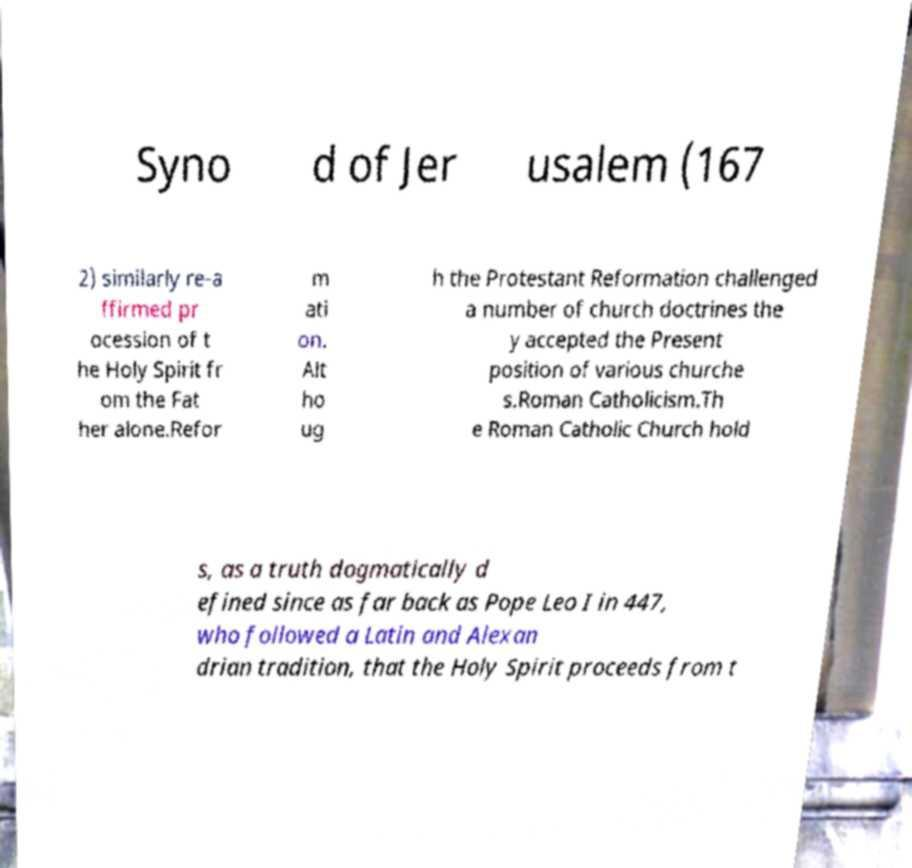There's text embedded in this image that I need extracted. Can you transcribe it verbatim? Syno d of Jer usalem (167 2) similarly re-a ffirmed pr ocession of t he Holy Spirit fr om the Fat her alone.Refor m ati on. Alt ho ug h the Protestant Reformation challenged a number of church doctrines the y accepted the Present position of various churche s.Roman Catholicism.Th e Roman Catholic Church hold s, as a truth dogmatically d efined since as far back as Pope Leo I in 447, who followed a Latin and Alexan drian tradition, that the Holy Spirit proceeds from t 